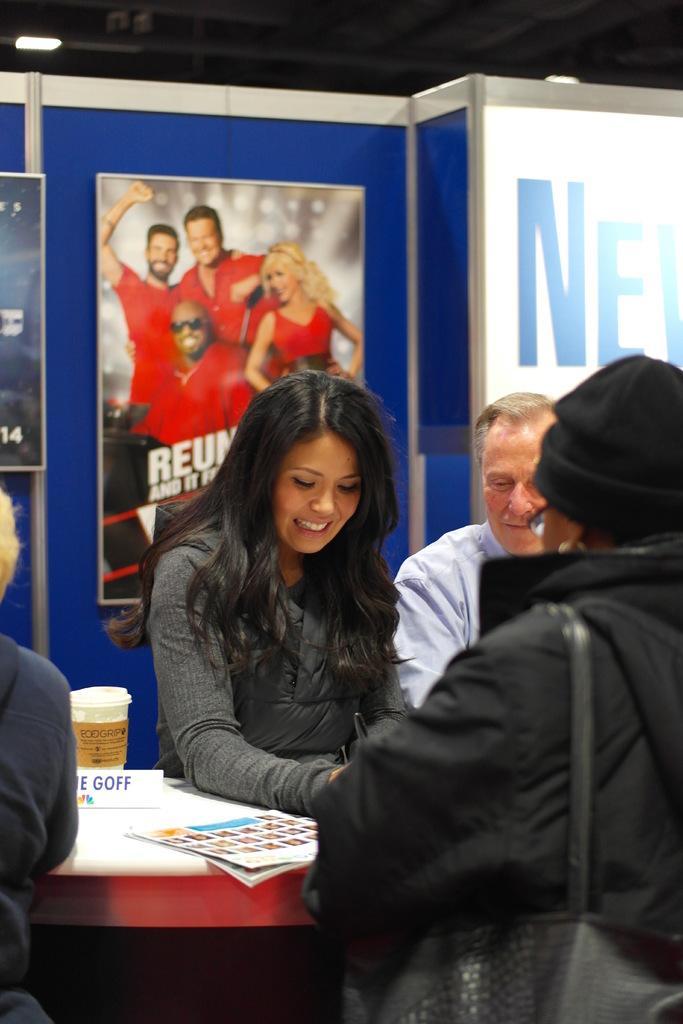Please provide a concise description of this image. In this picture we can see some persons in the middle. This is table and there is a cup. On the background we can see a hoarding. And this is light. 